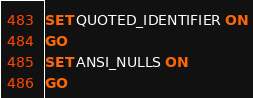<code> <loc_0><loc_0><loc_500><loc_500><_SQL_>SET QUOTED_IDENTIFIER ON
GO
SET ANSI_NULLS ON
GO</code> 